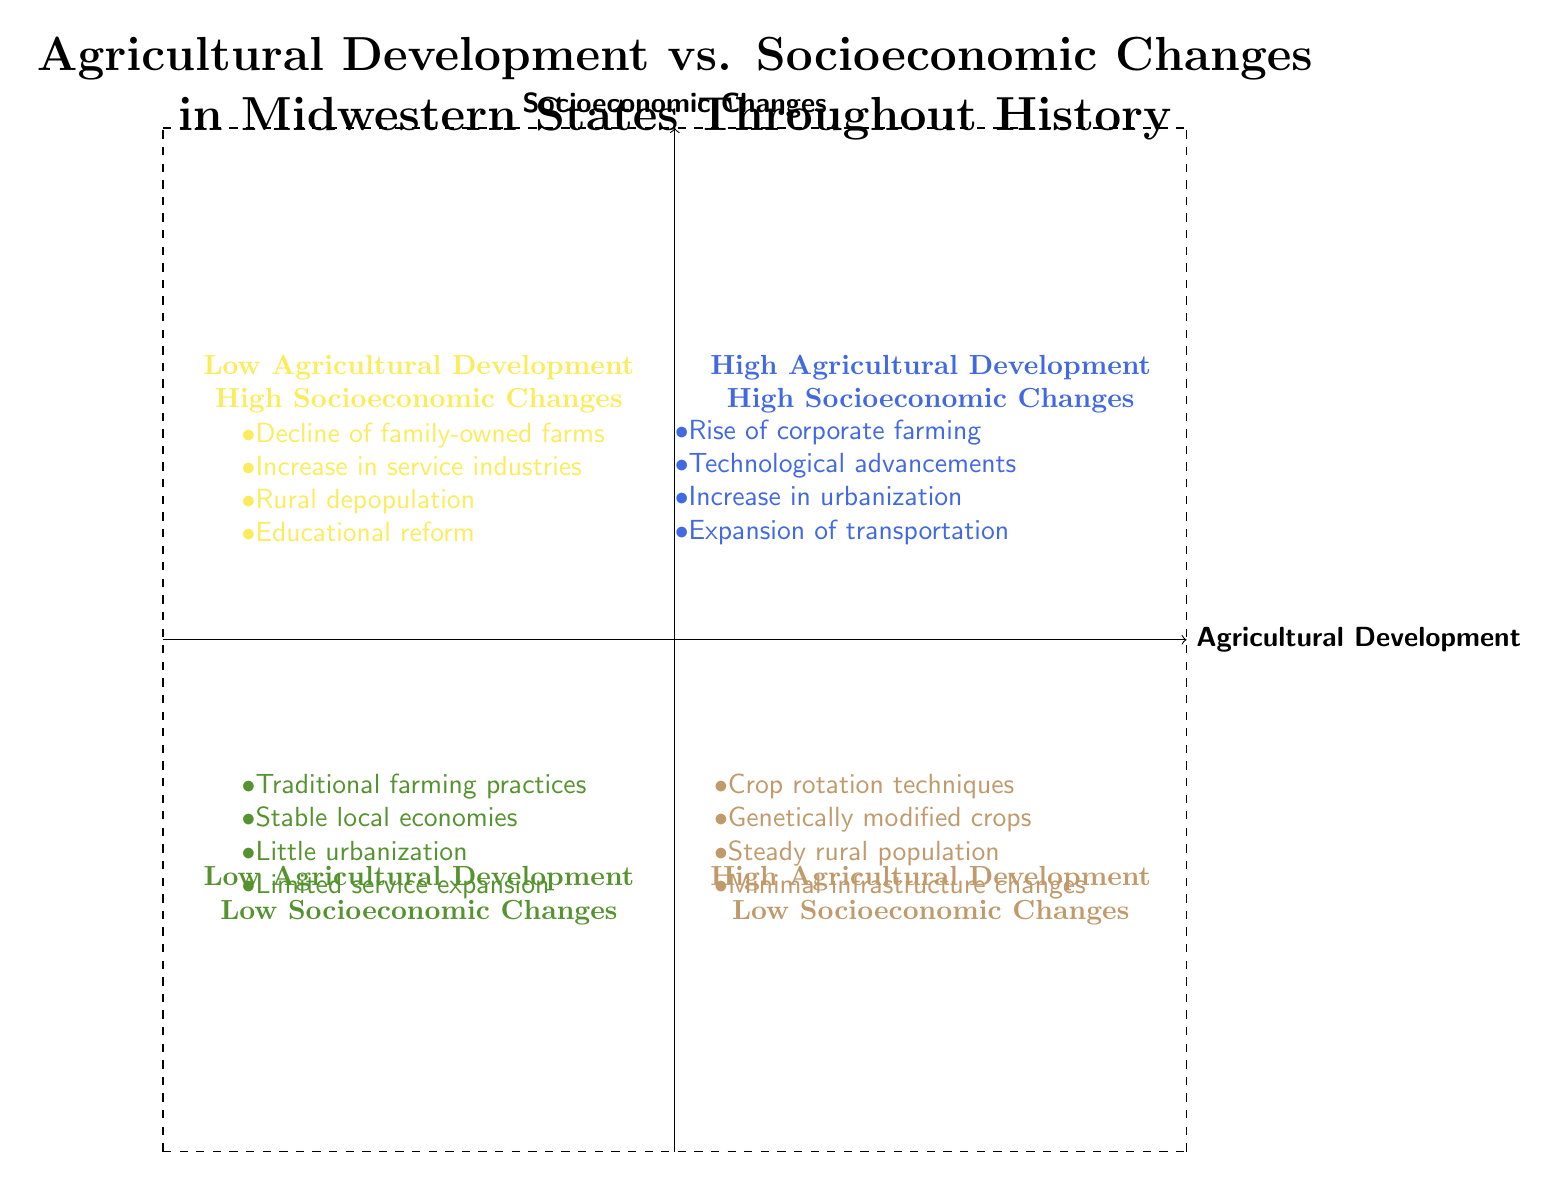What elements are listed in the "High Agricultural Development & High Socioeconomic Changes" quadrant? The "High Agricultural Development & High Socioeconomic Changes" quadrant includes the elements: Rise of corporate farming, Technological advancements in agriculture (e.g., John Deere equipment), Increase in urbanization and migration to cities, and Expansion of transportation networks (e.g., railroads, highways).
Answer: Rise of corporate farming, Technological advancements in agriculture (e.g., John Deere equipment), Increase in urbanization and migration to cities, Expansion of transportation networks (e.g., railroads, highways) How many elements are listed in the "Low Agricultural Development & High Socioeconomic Changes" quadrant? The "Low Agricultural Development & High Socioeconomic Changes" quadrant contains four elements: Decline of family-owned farms, Increase in service-oriented industries, Rural depopulation and growth of suburban areas, and Educational reform and improvements across the Midwest. Counting these gives us a total of four.
Answer: 4 In which quadrant would you find "Adoption of crop rotation and soil conservation techniques"? The "Adoption of crop rotation and soil conservation techniques" is listed in the "High Agricultural Development & Low Socioeconomic Changes" quadrant, as it signifies agricultural progress with limited socioeconomic changes.
Answer: High Agricultural Development & Low Socioeconomic Changes Which quadrant represents traditional farming practices with limited technological adoption? The quadrant that represents traditional farming practices with limited technological adoption is the "Low Agricultural Development & Low Socioeconomic Changes" quadrant.
Answer: Low Agricultural Development & Low Socioeconomic Changes What is the common theme of the elements found in the "Low Agricultural Development & High Socioeconomic Changes" quadrant? The common theme of the elements in the "Low Agricultural Development & High Socioeconomic Changes" quadrant revolves around the decline of traditional farming and the shift towards more urban, service-oriented economies, including aspects such as decline in family farms and educational reform.
Answer: Decline of traditional farming and a shift to urban economies Which quadrant contains the element "Increase in urbanization and migration to cities"? The element "Increase in urbanization and migration to cities" is found in the "High Agricultural Development & High Socioeconomic Changes" quadrant as it highlights the socioeconomic impact alongside agricultural development.
Answer: High Agricultural Development & High Socioeconomic Changes What comparison can be made between the "High Agricultural Development & High Socioeconomic Changes" and "High Agricultural Development & Low Socioeconomic Changes" quadrants? A comparison reveals that, while both quadrants showcase high agricultural development, the former indicates significant socioeconomic progress with urban migration and transportation expansion, whereas the latter shows limited socioeconomic changes and steady rural populations with minimal infrastructure improvements.
Answer: Significant socioeconomic progress vs. limited socioeconomic changes How does the number of elements in the "Low Agricultural Development & Low Socioeconomic Changes" quadrant compare to the "High Agricultural Development & Low Socioeconomic Changes" quadrant? Both quadrants contain four elements each, indicating that despite differing classifications, they both address similar levels of development and socioeconomic changes across their respective themes. Hence, the number of elements is equal.
Answer: Both quadrants have 4 elements each 